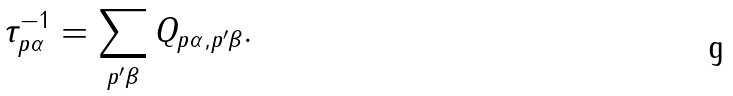<formula> <loc_0><loc_0><loc_500><loc_500>\tau ^ { - 1 } _ { { p } \alpha } = \sum _ { { p } ^ { \prime } \beta } Q _ { { p } \alpha , { p } ^ { \prime } \beta } .</formula> 